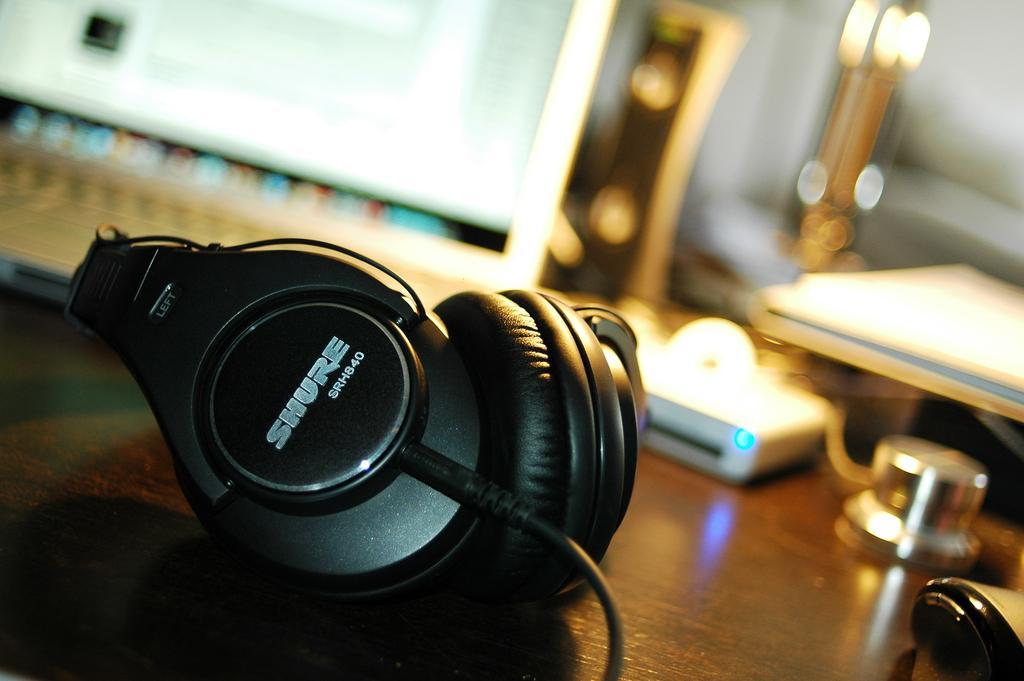Could you give a brief overview of what you see in this image? In this image we can see the microphone on the wooden surface. And we can see some other objects. And we can see the blurred background. 